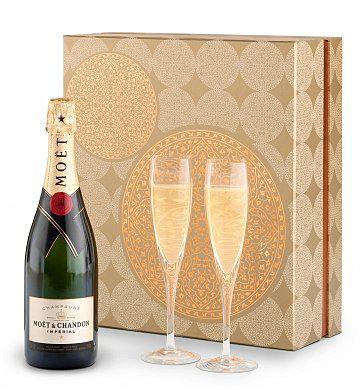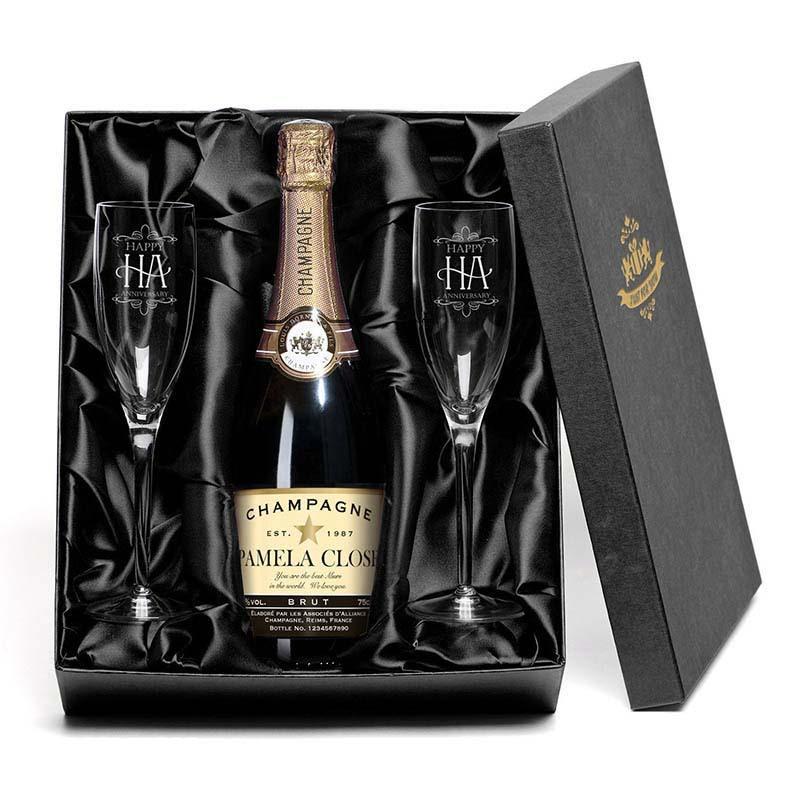The first image is the image on the left, the second image is the image on the right. Assess this claim about the two images: "Two glasses have champagne in them.". Correct or not? Answer yes or no. Yes. The first image is the image on the left, the second image is the image on the right. Evaluate the accuracy of this statement regarding the images: "Two wine glasses filled with liquid can be seen.". Is it true? Answer yes or no. Yes. 